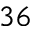<formula> <loc_0><loc_0><loc_500><loc_500>^ { 3 6 }</formula> 